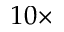Convert formula to latex. <formula><loc_0><loc_0><loc_500><loc_500>1 0 \times</formula> 